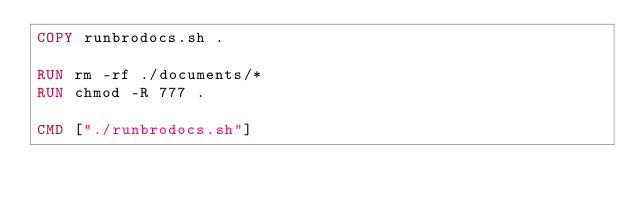<code> <loc_0><loc_0><loc_500><loc_500><_Dockerfile_>COPY runbrodocs.sh .

RUN rm -rf ./documents/*
RUN chmod -R 777 .

CMD ["./runbrodocs.sh"]
</code> 